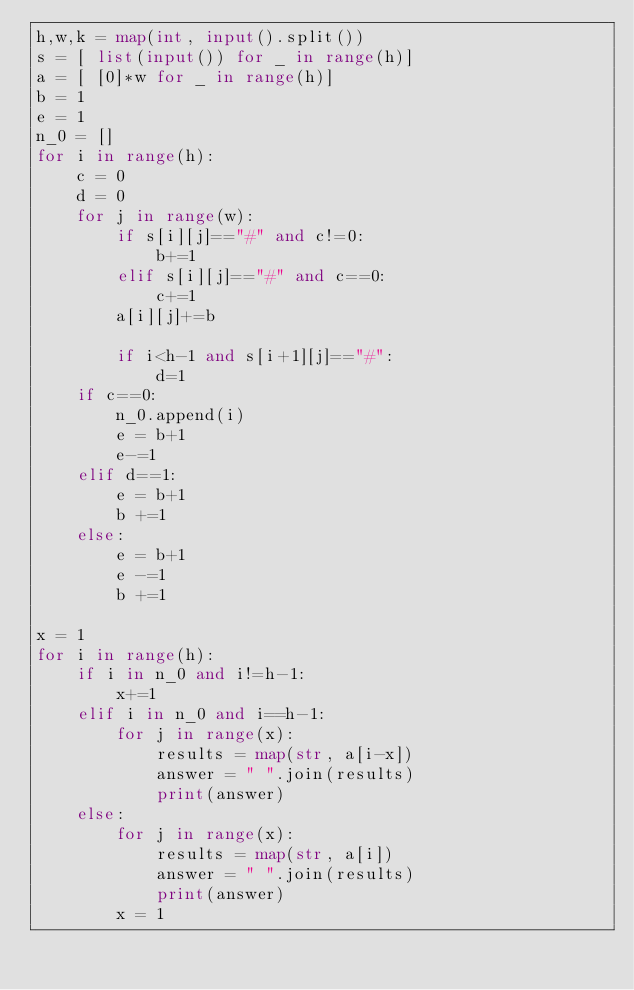Convert code to text. <code><loc_0><loc_0><loc_500><loc_500><_Python_>h,w,k = map(int, input().split())
s = [ list(input()) for _ in range(h)]
a = [ [0]*w for _ in range(h)]
b = 1
e = 1
n_0 = []
for i in range(h):
    c = 0
    d = 0
    for j in range(w):
        if s[i][j]=="#" and c!=0:
            b+=1
        elif s[i][j]=="#" and c==0:
            c+=1
        a[i][j]+=b

        if i<h-1 and s[i+1][j]=="#":
            d=1
    if c==0:
        n_0.append(i)
        e = b+1
        e-=1
    elif d==1:
        e = b+1
        b +=1
    else:
        e = b+1
        e -=1
        b +=1

x = 1
for i in range(h):
    if i in n_0 and i!=h-1:
        x+=1
    elif i in n_0 and i==h-1:
        for j in range(x):
            results = map(str, a[i-x])
            answer = " ".join(results)
            print(answer)
    else:
        for j in range(x):
            results = map(str, a[i])
            answer = " ".join(results)
            print(answer)
        x = 1</code> 